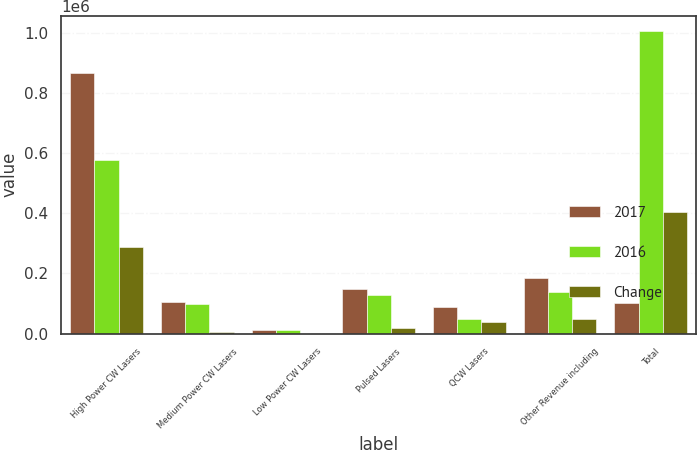Convert chart. <chart><loc_0><loc_0><loc_500><loc_500><stacked_bar_chart><ecel><fcel>High Power CW Lasers<fcel>Medium Power CW Lasers<fcel>Low Power CW Lasers<fcel>Pulsed Lasers<fcel>QCW Lasers<fcel>Other Revenue including<fcel>Total<nl><fcel>2017<fcel>867464<fcel>105547<fcel>13158<fcel>148701<fcel>88329<fcel>185690<fcel>102201<nl><fcel>2016<fcel>578668<fcel>98855<fcel>12788<fcel>128971<fcel>48612<fcel>138279<fcel>1.00617e+06<nl><fcel>Change<fcel>288796<fcel>6692<fcel>370<fcel>19730<fcel>39717<fcel>47411<fcel>402716<nl></chart> 